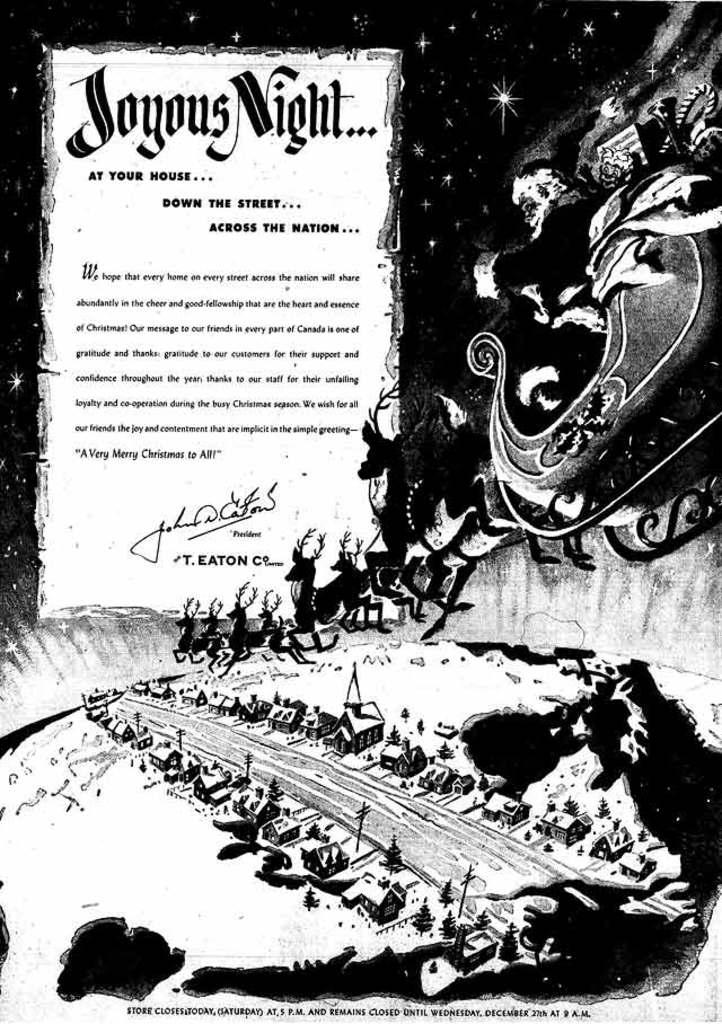<image>
Provide a brief description of the given image. a poster of Santa and sleigh with words about Joyous Night 